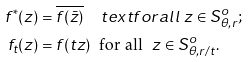Convert formula to latex. <formula><loc_0><loc_0><loc_500><loc_500>f ^ { * } ( z ) & = \overline { f ( \bar { z } ) } \quad t e x t { f o r a l l } \ z \in S _ { \theta , r } ^ { o } ; \\ f _ { t } ( z ) & = f ( t z ) \ \text { for all } \ z \in S _ { \theta , r / t } ^ { o } .</formula> 